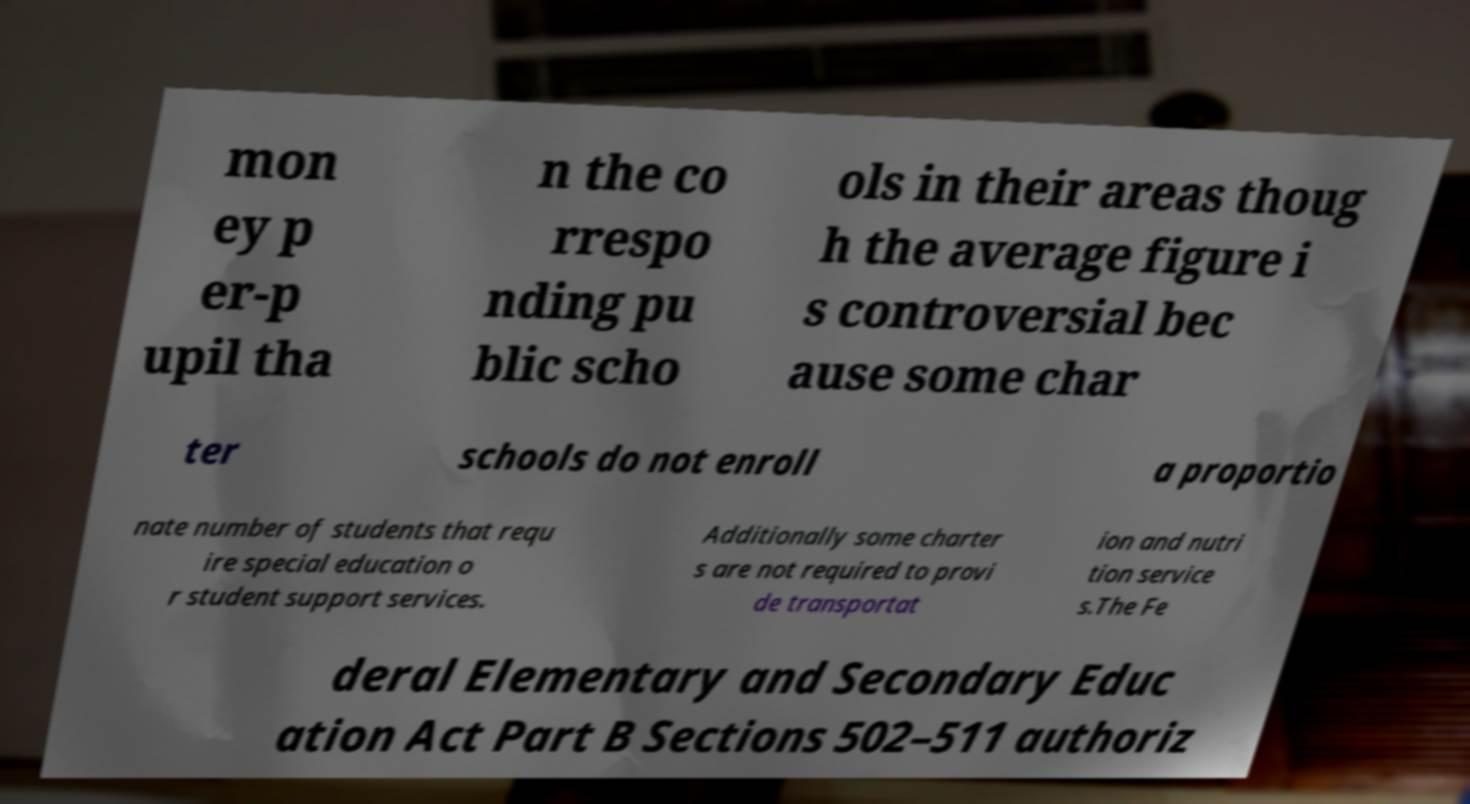Please identify and transcribe the text found in this image. mon ey p er-p upil tha n the co rrespo nding pu blic scho ols in their areas thoug h the average figure i s controversial bec ause some char ter schools do not enroll a proportio nate number of students that requ ire special education o r student support services. Additionally some charter s are not required to provi de transportat ion and nutri tion service s.The Fe deral Elementary and Secondary Educ ation Act Part B Sections 502–511 authoriz 